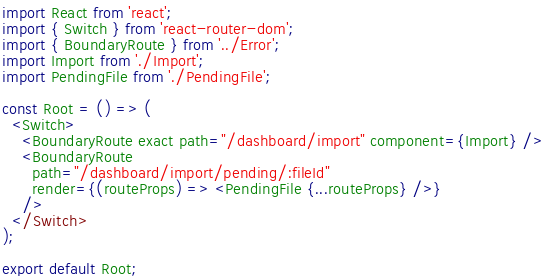Convert code to text. <code><loc_0><loc_0><loc_500><loc_500><_JavaScript_>import React from 'react';
import { Switch } from 'react-router-dom';
import { BoundaryRoute } from '../Error';
import Import from './Import';
import PendingFile from './PendingFile';

const Root = () => (
  <Switch>
    <BoundaryRoute exact path="/dashboard/import" component={Import} />
    <BoundaryRoute
      path="/dashboard/import/pending/:fileId"
      render={(routeProps) => <PendingFile {...routeProps} />}
    />
  </Switch>
);

export default Root;
</code> 